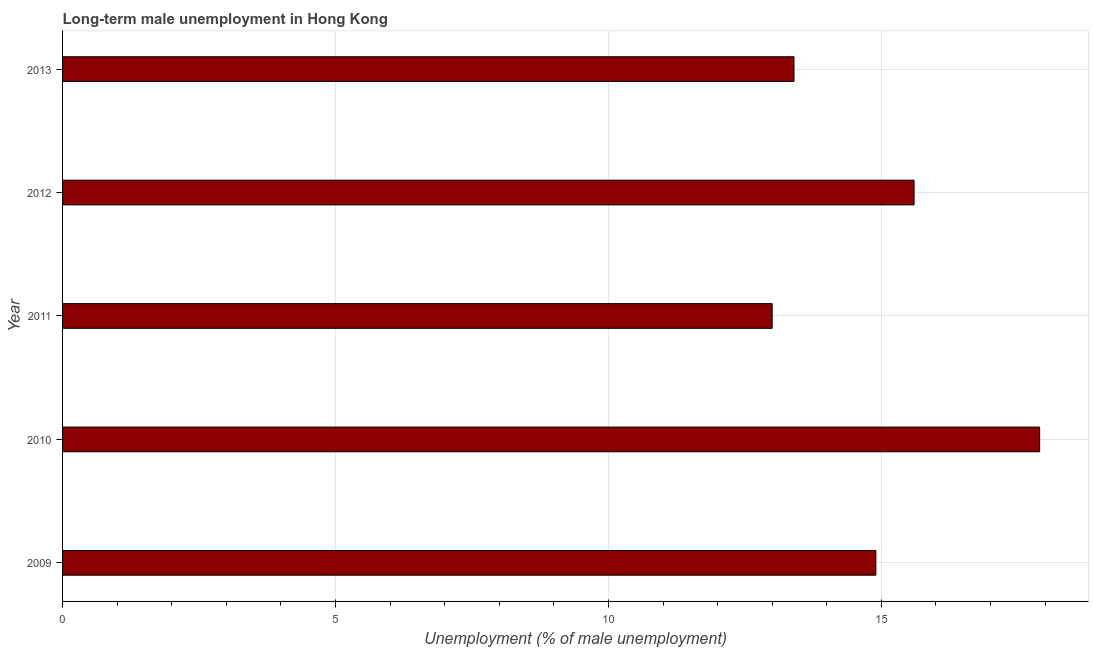Does the graph contain any zero values?
Offer a very short reply. No. Does the graph contain grids?
Offer a very short reply. Yes. What is the title of the graph?
Give a very brief answer. Long-term male unemployment in Hong Kong. What is the label or title of the X-axis?
Offer a very short reply. Unemployment (% of male unemployment). What is the label or title of the Y-axis?
Your answer should be very brief. Year. What is the long-term male unemployment in 2009?
Your answer should be compact. 14.9. Across all years, what is the maximum long-term male unemployment?
Give a very brief answer. 17.9. Across all years, what is the minimum long-term male unemployment?
Your answer should be compact. 13. In which year was the long-term male unemployment maximum?
Your answer should be very brief. 2010. What is the sum of the long-term male unemployment?
Your answer should be very brief. 74.8. What is the average long-term male unemployment per year?
Give a very brief answer. 14.96. What is the median long-term male unemployment?
Offer a very short reply. 14.9. In how many years, is the long-term male unemployment greater than 4 %?
Your answer should be compact. 5. What is the ratio of the long-term male unemployment in 2010 to that in 2011?
Offer a very short reply. 1.38. Is the difference between the long-term male unemployment in 2009 and 2010 greater than the difference between any two years?
Keep it short and to the point. No. Is the sum of the long-term male unemployment in 2009 and 2010 greater than the maximum long-term male unemployment across all years?
Provide a succinct answer. Yes. In how many years, is the long-term male unemployment greater than the average long-term male unemployment taken over all years?
Provide a succinct answer. 2. Are all the bars in the graph horizontal?
Offer a very short reply. Yes. How many years are there in the graph?
Ensure brevity in your answer.  5. What is the difference between two consecutive major ticks on the X-axis?
Keep it short and to the point. 5. What is the Unemployment (% of male unemployment) in 2009?
Provide a short and direct response. 14.9. What is the Unemployment (% of male unemployment) of 2010?
Offer a very short reply. 17.9. What is the Unemployment (% of male unemployment) in 2012?
Your answer should be very brief. 15.6. What is the Unemployment (% of male unemployment) in 2013?
Make the answer very short. 13.4. What is the difference between the Unemployment (% of male unemployment) in 2009 and 2013?
Your answer should be very brief. 1.5. What is the difference between the Unemployment (% of male unemployment) in 2010 and 2013?
Provide a succinct answer. 4.5. What is the difference between the Unemployment (% of male unemployment) in 2011 and 2013?
Give a very brief answer. -0.4. What is the difference between the Unemployment (% of male unemployment) in 2012 and 2013?
Your response must be concise. 2.2. What is the ratio of the Unemployment (% of male unemployment) in 2009 to that in 2010?
Offer a terse response. 0.83. What is the ratio of the Unemployment (% of male unemployment) in 2009 to that in 2011?
Keep it short and to the point. 1.15. What is the ratio of the Unemployment (% of male unemployment) in 2009 to that in 2012?
Your answer should be very brief. 0.95. What is the ratio of the Unemployment (% of male unemployment) in 2009 to that in 2013?
Provide a short and direct response. 1.11. What is the ratio of the Unemployment (% of male unemployment) in 2010 to that in 2011?
Ensure brevity in your answer.  1.38. What is the ratio of the Unemployment (% of male unemployment) in 2010 to that in 2012?
Offer a very short reply. 1.15. What is the ratio of the Unemployment (% of male unemployment) in 2010 to that in 2013?
Offer a very short reply. 1.34. What is the ratio of the Unemployment (% of male unemployment) in 2011 to that in 2012?
Ensure brevity in your answer.  0.83. What is the ratio of the Unemployment (% of male unemployment) in 2012 to that in 2013?
Offer a terse response. 1.16. 